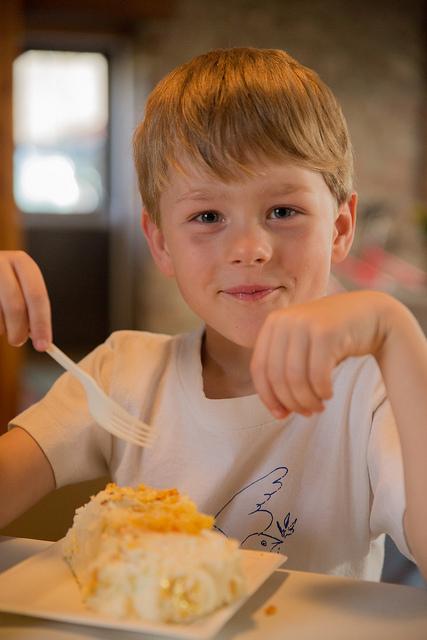Is the child a girl or a boy?
Short answer required. Boy. What is on top of the cake?
Keep it brief. Icing. What is the kid holding?
Concise answer only. Fork. What are the animals on the child's sweater?
Keep it brief. Bird. What color is his eyes?
Write a very short answer. Brown. Are there stripes on his t shirt?
Quick response, please. No. How many humans are in the image?
Answer briefly. 1. Is this young person wearing glasses?
Short answer required. No. Is this a baby?
Be succinct. No. Where did the family get their breakfast?
Quick response, please. Home. What is on the boys shirt?
Short answer required. Bird. What kind of food is he eating?
Keep it brief. Cake. Is this child old enough to brush his own teeth?
Concise answer only. Yes. Is this boy eating with his hands or a fork?
Answer briefly. Fork. Is that ice cream or mashed potato?
Be succinct. Mashed potato. 